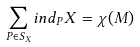Convert formula to latex. <formula><loc_0><loc_0><loc_500><loc_500>\sum _ { P \in S _ { X } } i n d _ { P } X = \chi ( M )</formula> 